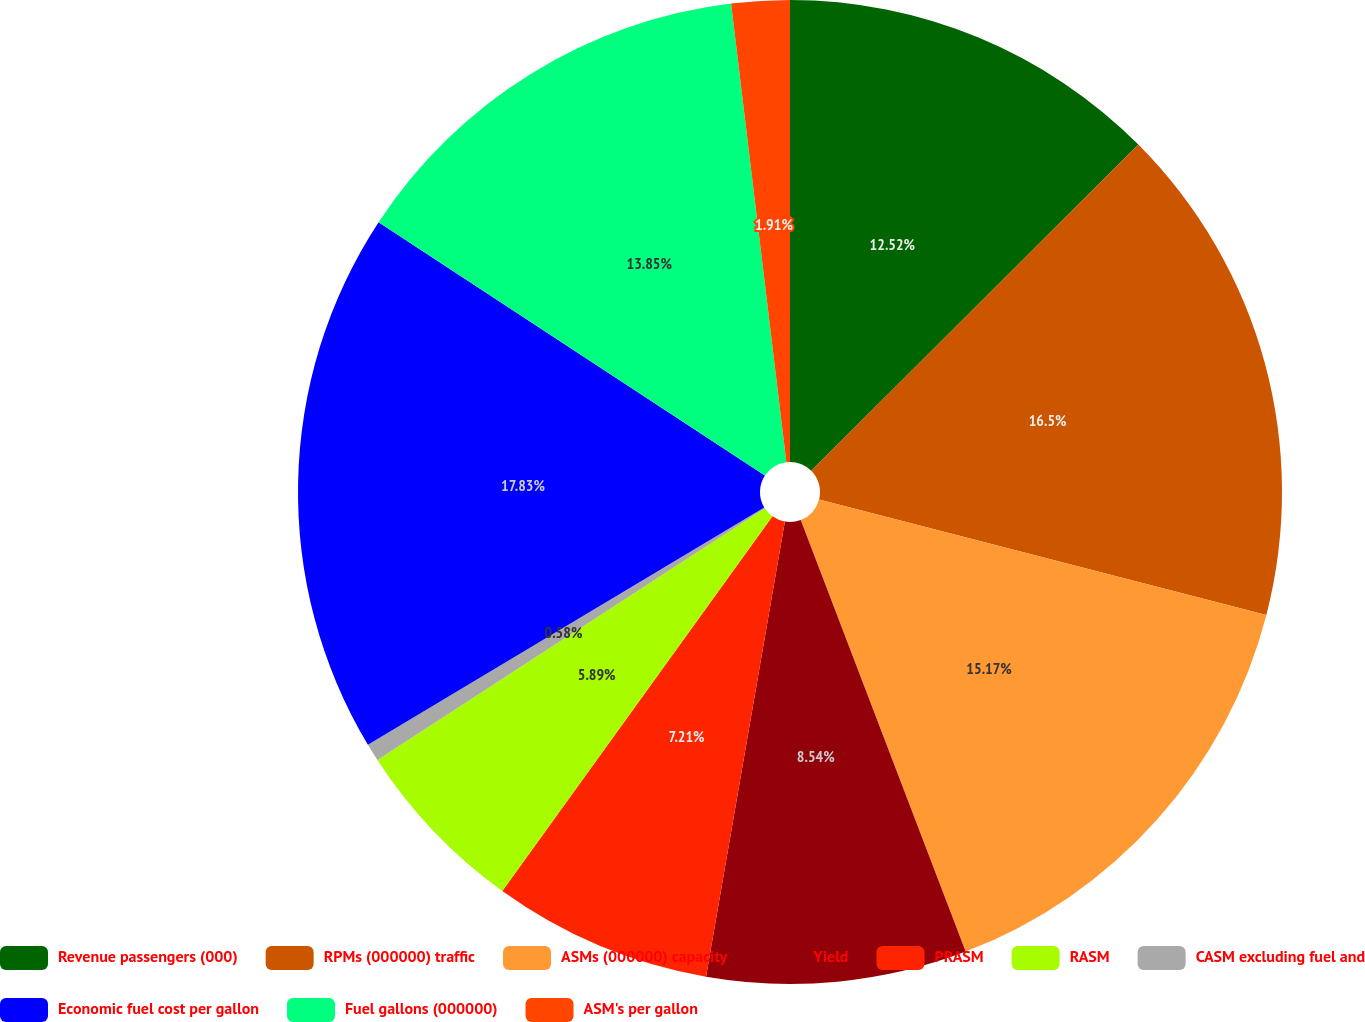Convert chart. <chart><loc_0><loc_0><loc_500><loc_500><pie_chart><fcel>Revenue passengers (000)<fcel>RPMs (000000) traffic<fcel>ASMs (000000) capacity<fcel>Yield<fcel>PRASM<fcel>RASM<fcel>CASM excluding fuel and<fcel>Economic fuel cost per gallon<fcel>Fuel gallons (000000)<fcel>ASM's per gallon<nl><fcel>12.52%<fcel>16.5%<fcel>15.17%<fcel>8.54%<fcel>7.21%<fcel>5.89%<fcel>0.58%<fcel>17.83%<fcel>13.85%<fcel>1.91%<nl></chart> 